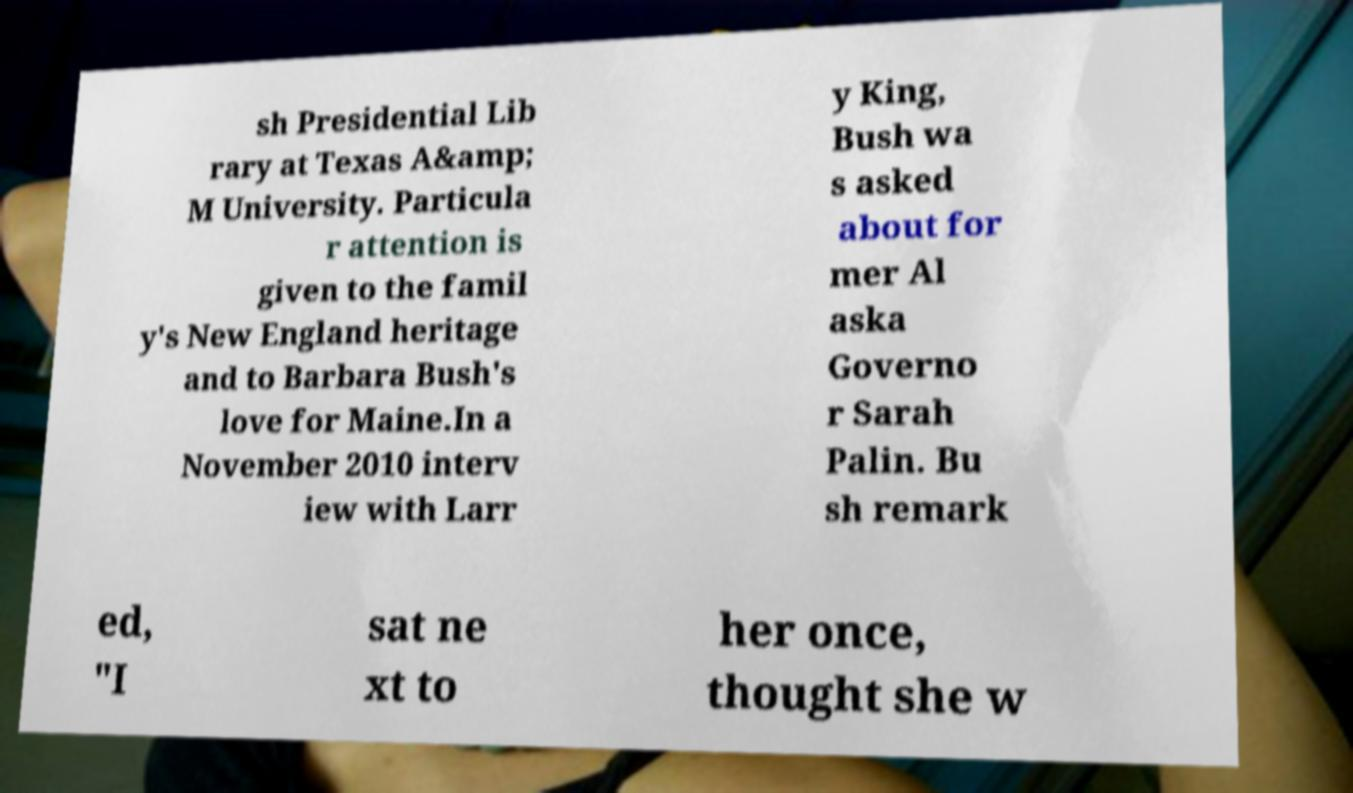Can you read and provide the text displayed in the image?This photo seems to have some interesting text. Can you extract and type it out for me? sh Presidential Lib rary at Texas A&amp; M University. Particula r attention is given to the famil y's New England heritage and to Barbara Bush's love for Maine.In a November 2010 interv iew with Larr y King, Bush wa s asked about for mer Al aska Governo r Sarah Palin. Bu sh remark ed, "I sat ne xt to her once, thought she w 